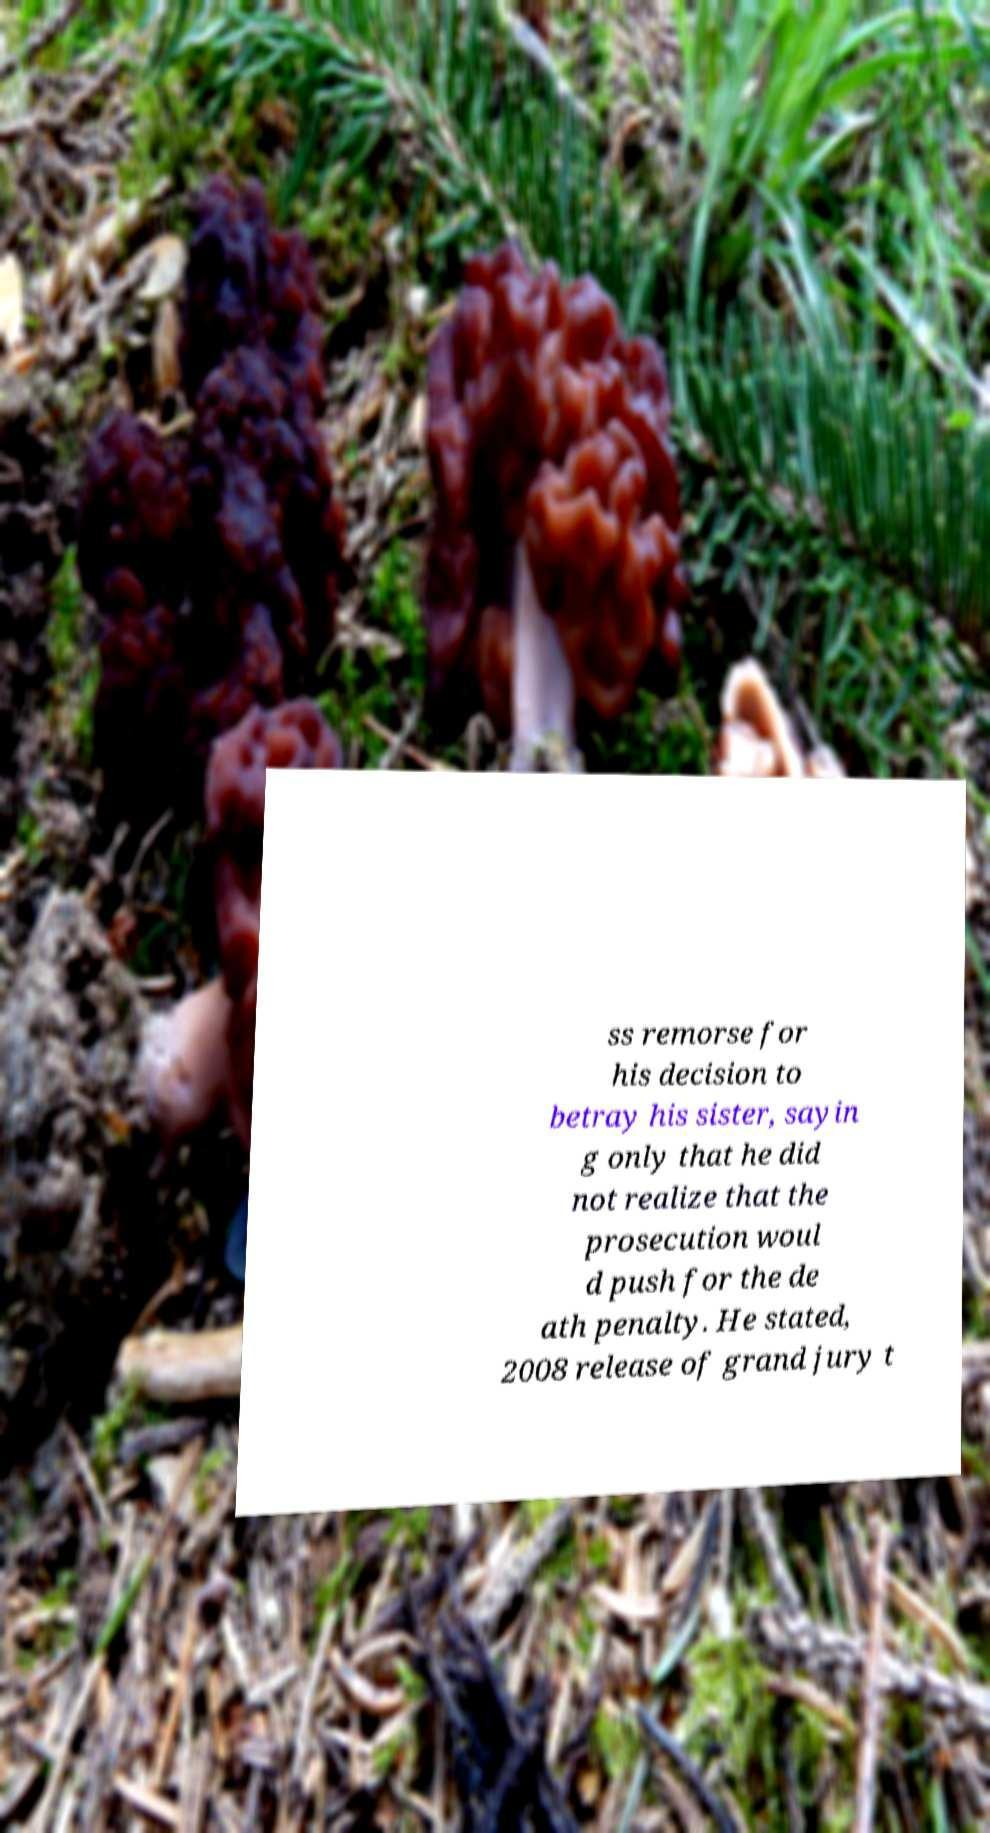Please read and relay the text visible in this image. What does it say? ss remorse for his decision to betray his sister, sayin g only that he did not realize that the prosecution woul d push for the de ath penalty. He stated, 2008 release of grand jury t 